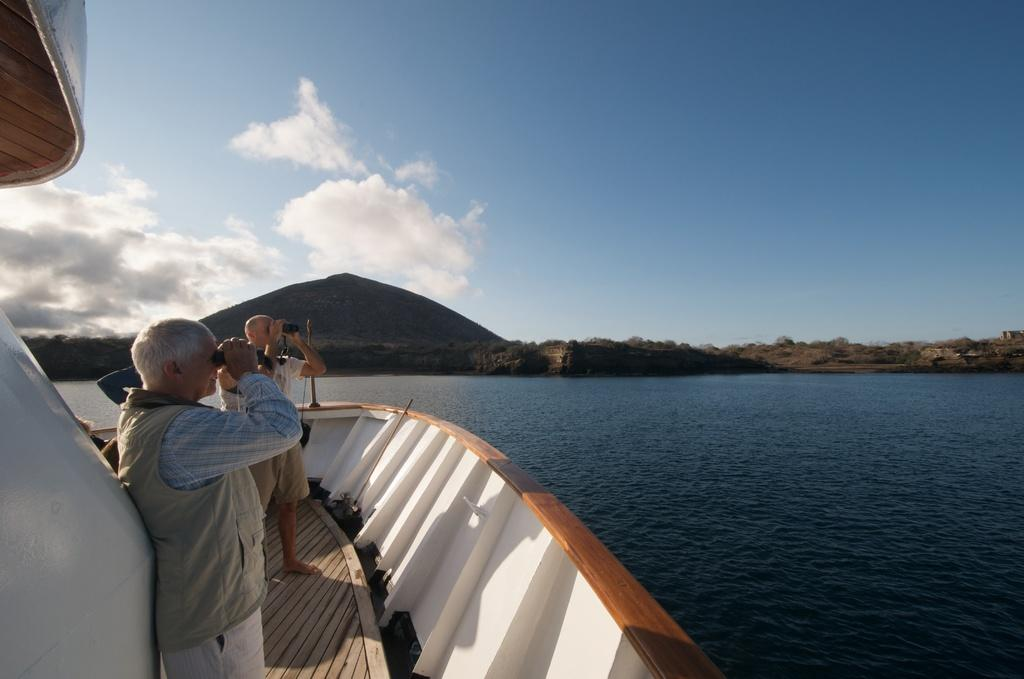How many people are in the image? There are people in the image, but the exact number is not specified. What are two people doing in the image? Two people are holding something in the image. Where are the people located in the image? They are on a ship in the image. What type of landscape can be seen in the image? Mountains and trees are visible in the image. What natural element is present in the image? Water is visible in the image. What is the color of the sky in the image? The sky is blue in the image. What is the chance of a tramp winning the lottery in the image? There is no tramp or lottery mentioned in the image, so it is not possible to determine the chance of a tramp winning the lottery. What is the common interest of the people in the image? The common interest of the people in the image is not specified, as their actions and the context of the image are not detailed enough to determine a shared interest. 